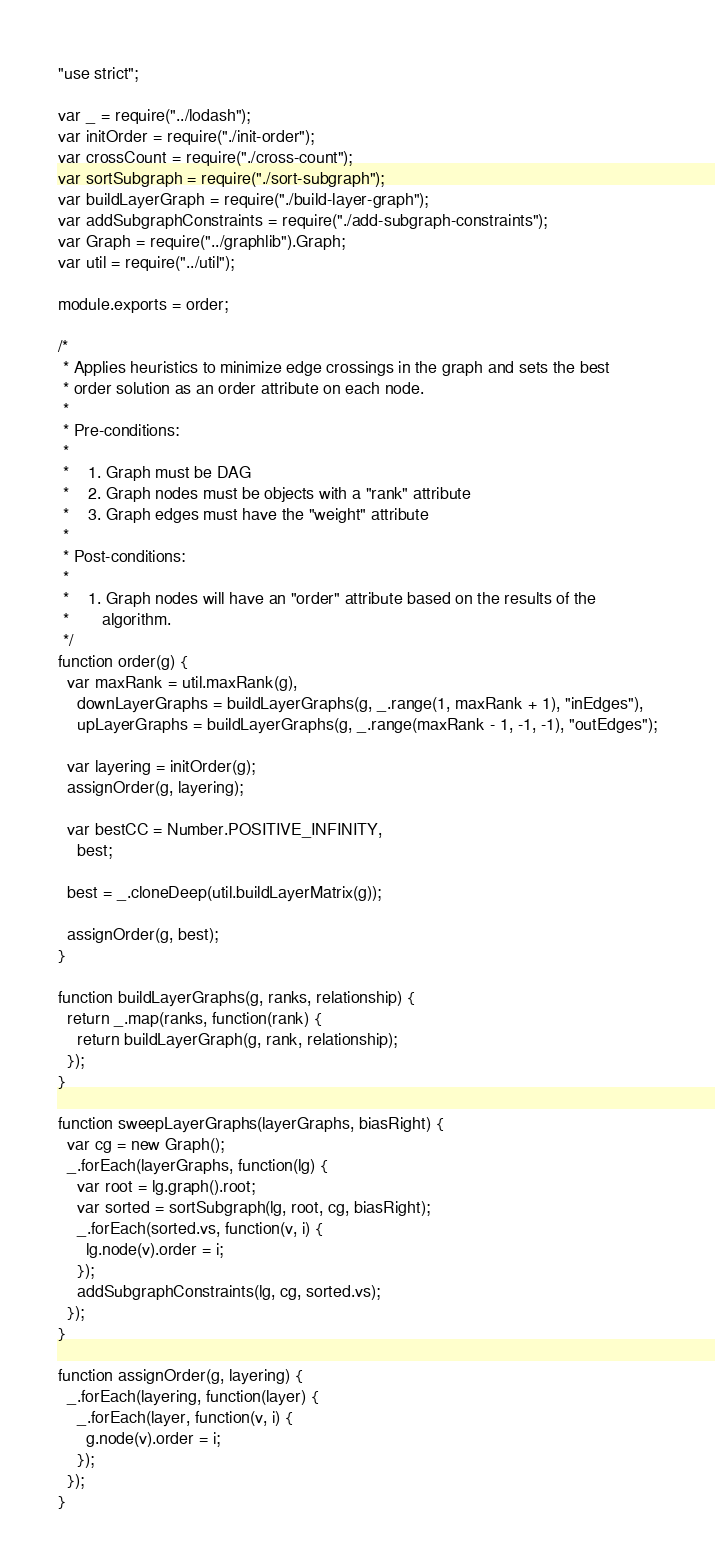Convert code to text. <code><loc_0><loc_0><loc_500><loc_500><_JavaScript_>"use strict";

var _ = require("../lodash");
var initOrder = require("./init-order");
var crossCount = require("./cross-count");
var sortSubgraph = require("./sort-subgraph");
var buildLayerGraph = require("./build-layer-graph");
var addSubgraphConstraints = require("./add-subgraph-constraints");
var Graph = require("../graphlib").Graph;
var util = require("../util");

module.exports = order;

/*
 * Applies heuristics to minimize edge crossings in the graph and sets the best
 * order solution as an order attribute on each node.
 *
 * Pre-conditions:
 *
 *    1. Graph must be DAG
 *    2. Graph nodes must be objects with a "rank" attribute
 *    3. Graph edges must have the "weight" attribute
 *
 * Post-conditions:
 *
 *    1. Graph nodes will have an "order" attribute based on the results of the
 *       algorithm.
 */
function order(g) {
  var maxRank = util.maxRank(g),
    downLayerGraphs = buildLayerGraphs(g, _.range(1, maxRank + 1), "inEdges"),
    upLayerGraphs = buildLayerGraphs(g, _.range(maxRank - 1, -1, -1), "outEdges");

  var layering = initOrder(g);
  assignOrder(g, layering);

  var bestCC = Number.POSITIVE_INFINITY,
    best;

  best = _.cloneDeep(util.buildLayerMatrix(g));

  assignOrder(g, best);
}

function buildLayerGraphs(g, ranks, relationship) {
  return _.map(ranks, function(rank) {
    return buildLayerGraph(g, rank, relationship);
  });
}

function sweepLayerGraphs(layerGraphs, biasRight) {
  var cg = new Graph();
  _.forEach(layerGraphs, function(lg) {
    var root = lg.graph().root;
    var sorted = sortSubgraph(lg, root, cg, biasRight);
    _.forEach(sorted.vs, function(v, i) {
      lg.node(v).order = i;
    });
    addSubgraphConstraints(lg, cg, sorted.vs);
  });
}

function assignOrder(g, layering) {
  _.forEach(layering, function(layer) {
    _.forEach(layer, function(v, i) {
      g.node(v).order = i;
    });
  });
}
</code> 